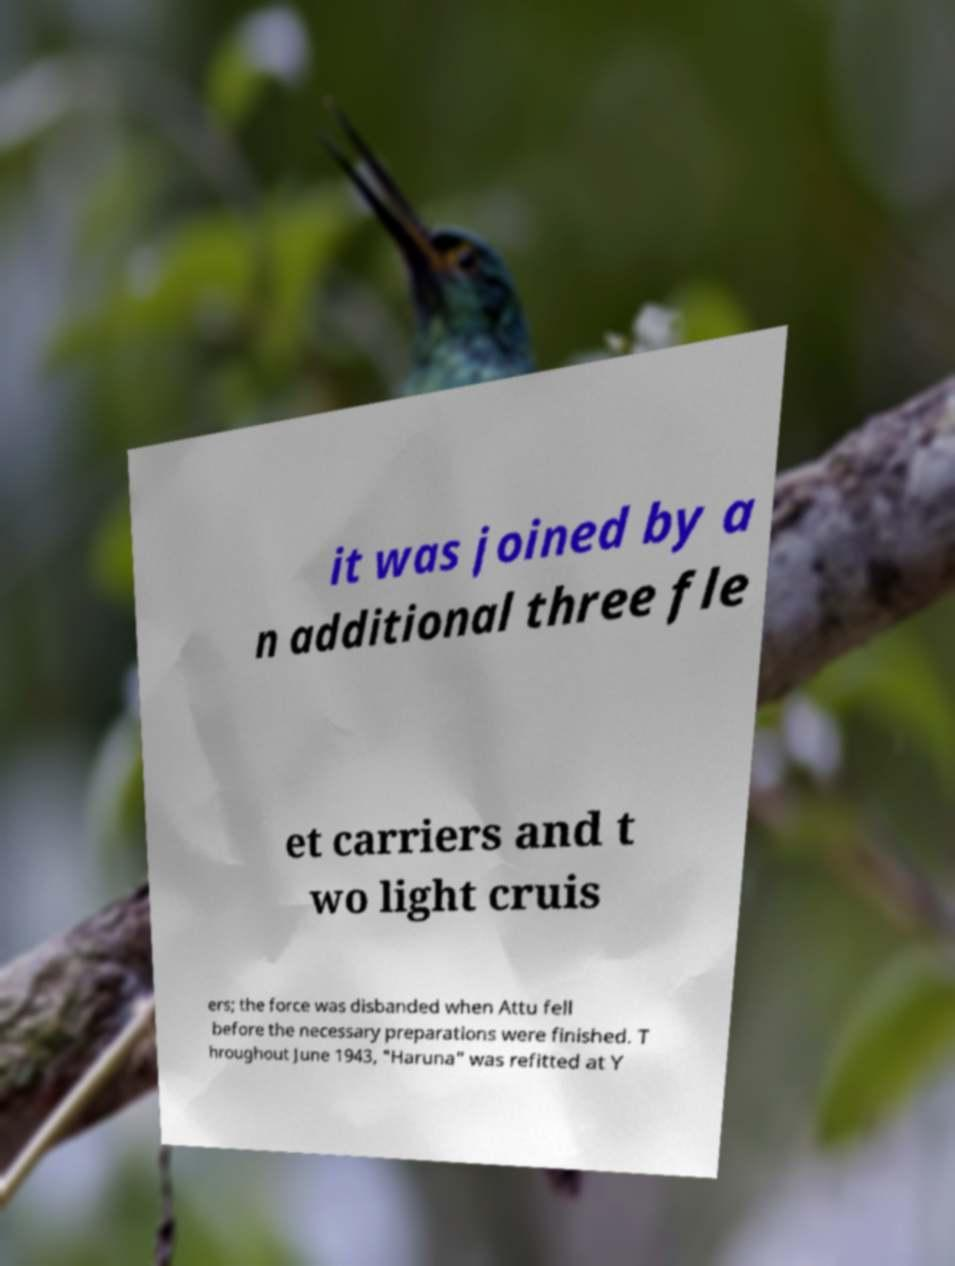Can you read and provide the text displayed in the image?This photo seems to have some interesting text. Can you extract and type it out for me? it was joined by a n additional three fle et carriers and t wo light cruis ers; the force was disbanded when Attu fell before the necessary preparations were finished. T hroughout June 1943, "Haruna" was refitted at Y 